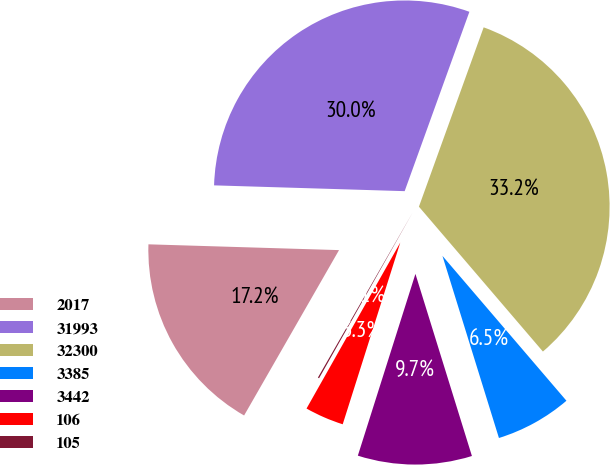Convert chart to OTSL. <chart><loc_0><loc_0><loc_500><loc_500><pie_chart><fcel>2017<fcel>31993<fcel>32300<fcel>3385<fcel>3442<fcel>106<fcel>105<nl><fcel>17.19%<fcel>30.03%<fcel>33.22%<fcel>6.48%<fcel>9.67%<fcel>3.3%<fcel>0.11%<nl></chart> 